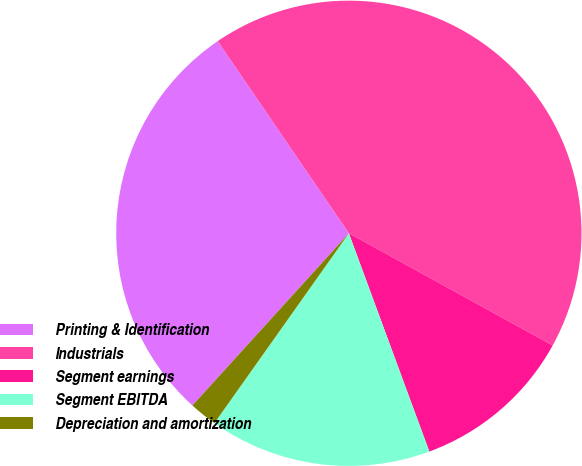Convert chart. <chart><loc_0><loc_0><loc_500><loc_500><pie_chart><fcel>Printing & Identification<fcel>Industrials<fcel>Segment earnings<fcel>Segment EBITDA<fcel>Depreciation and amortization<nl><fcel>28.73%<fcel>42.54%<fcel>11.37%<fcel>15.43%<fcel>1.93%<nl></chart> 